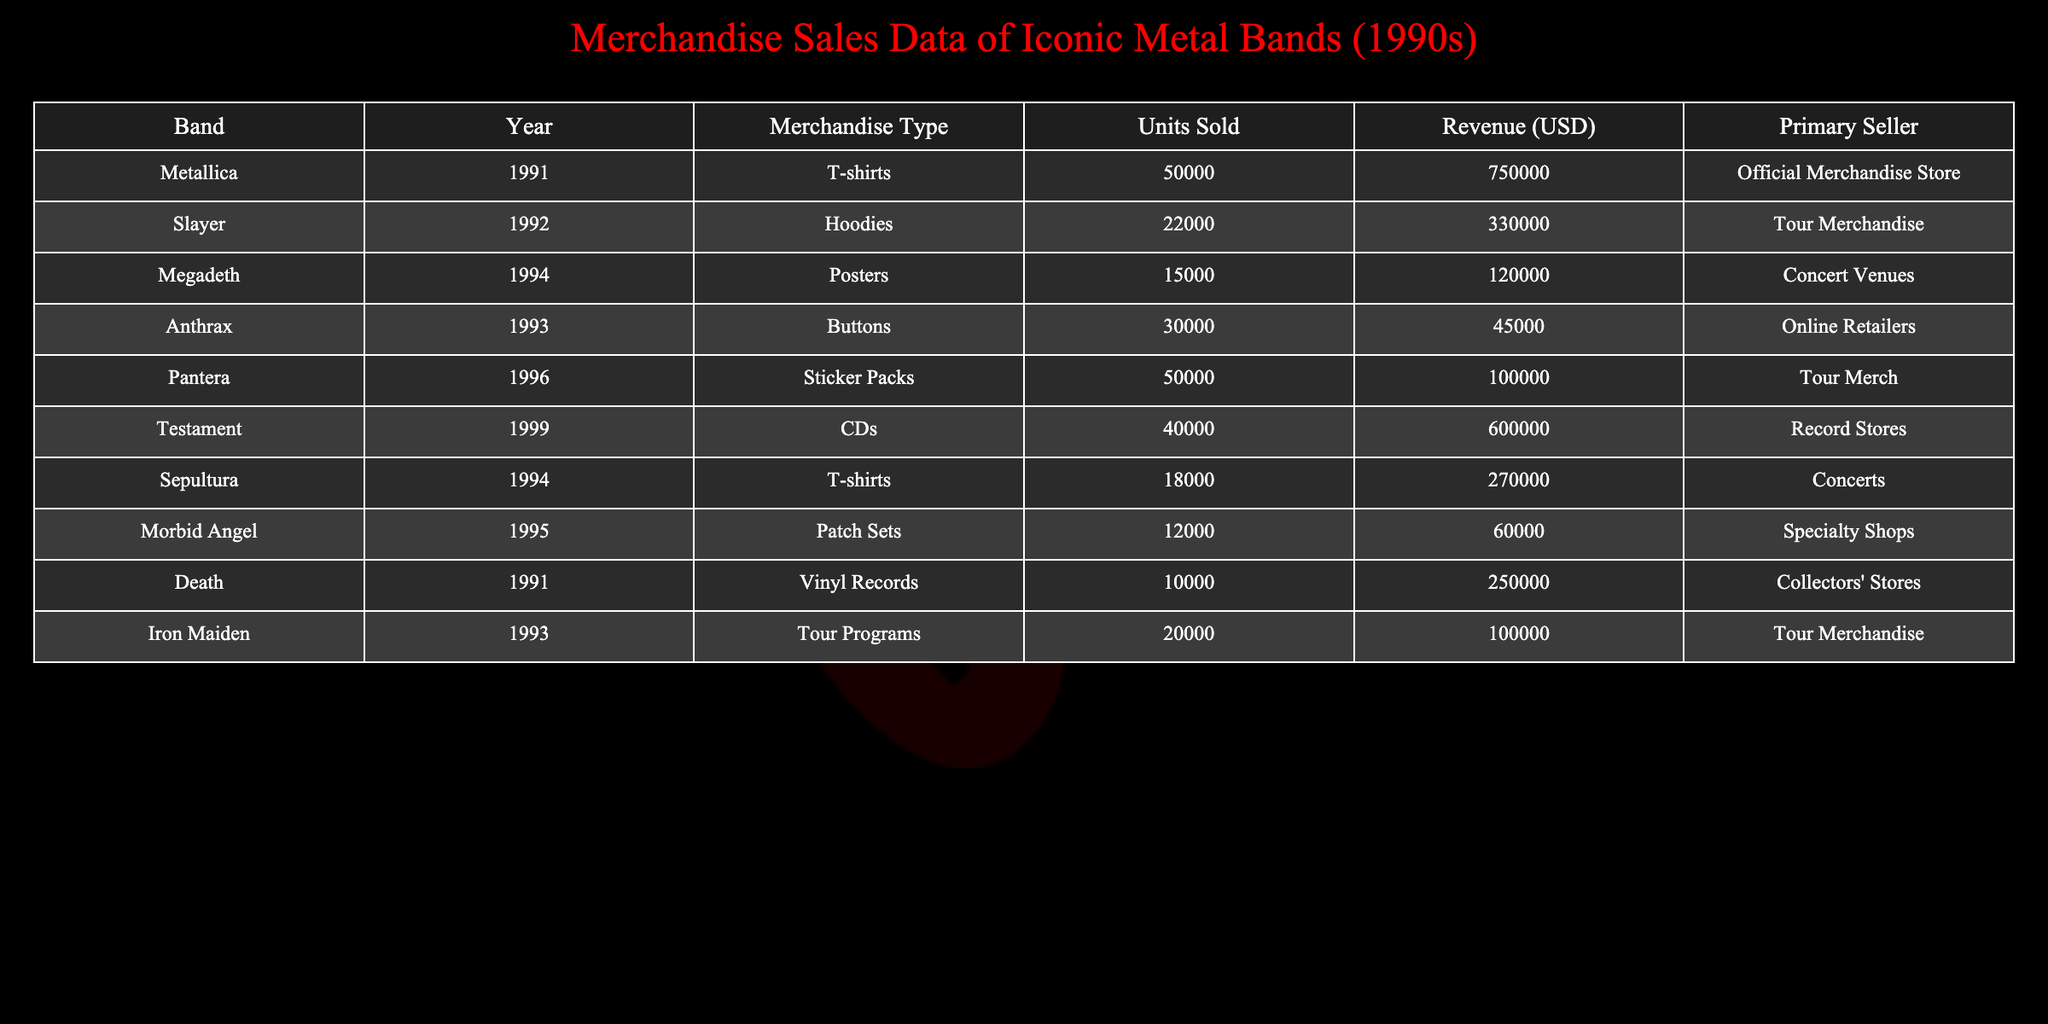What type of merchandise generated the highest revenue in 1991? In 1991, Metallica sold T-shirts, generating a revenue of 750,000 USD, which is the highest revenue listed for that year.
Answer: T-shirts How many units of merchandise did Slayer sell in 1992? According to the table, Slayer sold 22,000 units of hoodies in 1992.
Answer: 22,000 What is the total revenue from the merchandise sales of Megadeth and Death? Adding the revenue from Megadeth's posters (120,000 USD) and Death's vinyl records (250,000 USD) gives a total of 370,000 USD.
Answer: 370,000 Did Iron Maiden sell more than 25,000 units of merchandise in 1993? Iron Maiden sold 20,000 units of tour programs in 1993, which is less than 25,000.
Answer: No What is the average revenue generated from the merchandise sold by all the bands in 1994? The total revenue for 1994 includes Megadeth's 120,000 USD, Sepultura's 270,000 USD, and Morbid Angel's 60,000 USD, totaling 450,000 USD for three bands. The average is 450,000 / 3 = 150,000 USD.
Answer: 150,000 Which band sold the second-highest number of units after Metallica in 1991? After Metallica, who sold 50,000 T-shirts, Pantera sold 50,000 sticker packs in 1996, but since we're comparing only in 1991, there isn't a second in that year. From 1991 to 1999, Pantera stands as the second-highest sold, but in 1991, Death, with vinyl records, sold 10,000.
Answer: Death (10,000) What is the total number of units sold by Anthrax and Pantera combined? Anthrax sold 30,000 buttons, and Pantera sold 50,000 sticker packs. The total is 30,000 + 50,000 = 80,000 units.
Answer: 80,000 Did any band in the table sell more than 40,000 units of merchandise? Yes, both Metallica (50,000 T-shirts) and Pantera (50,000 sticker packs) sold more than 40,000 units.
Answer: Yes 